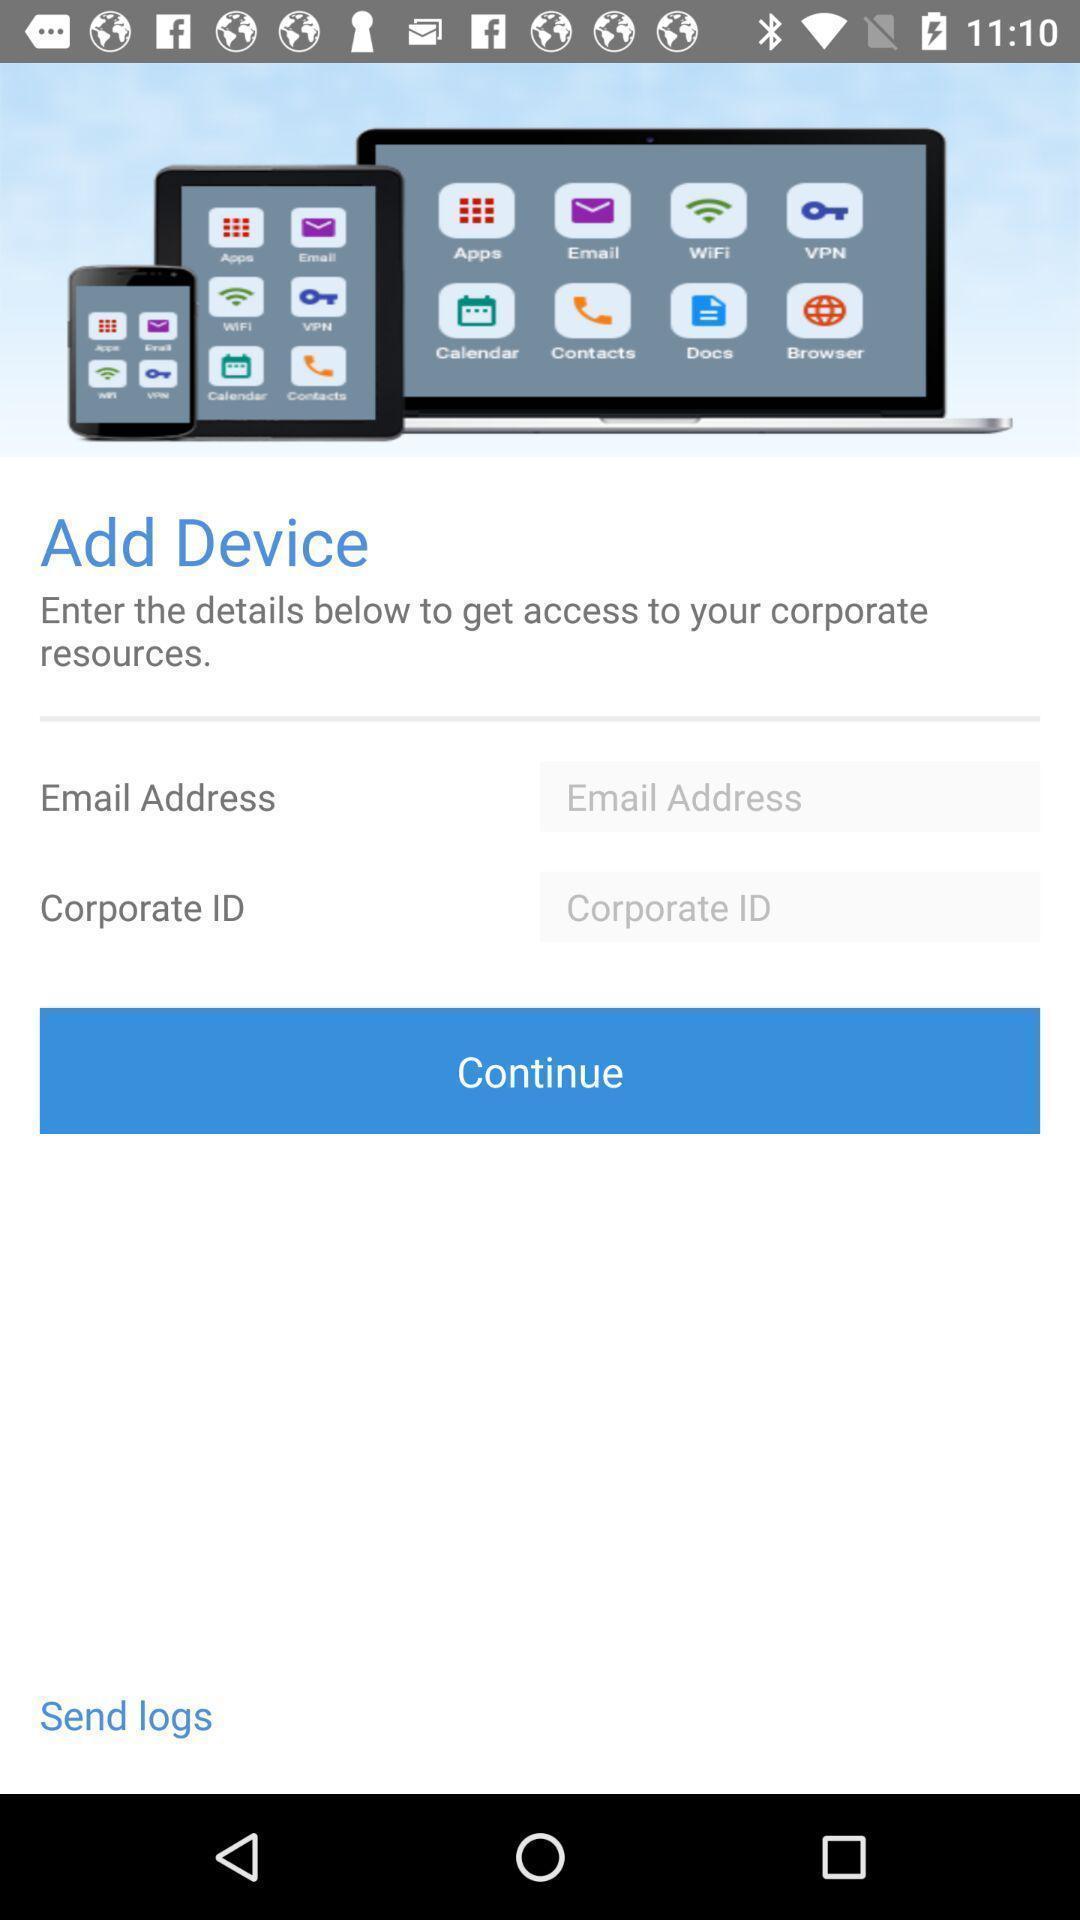What is the overall content of this screenshot? Welcome page for a remote access app. 